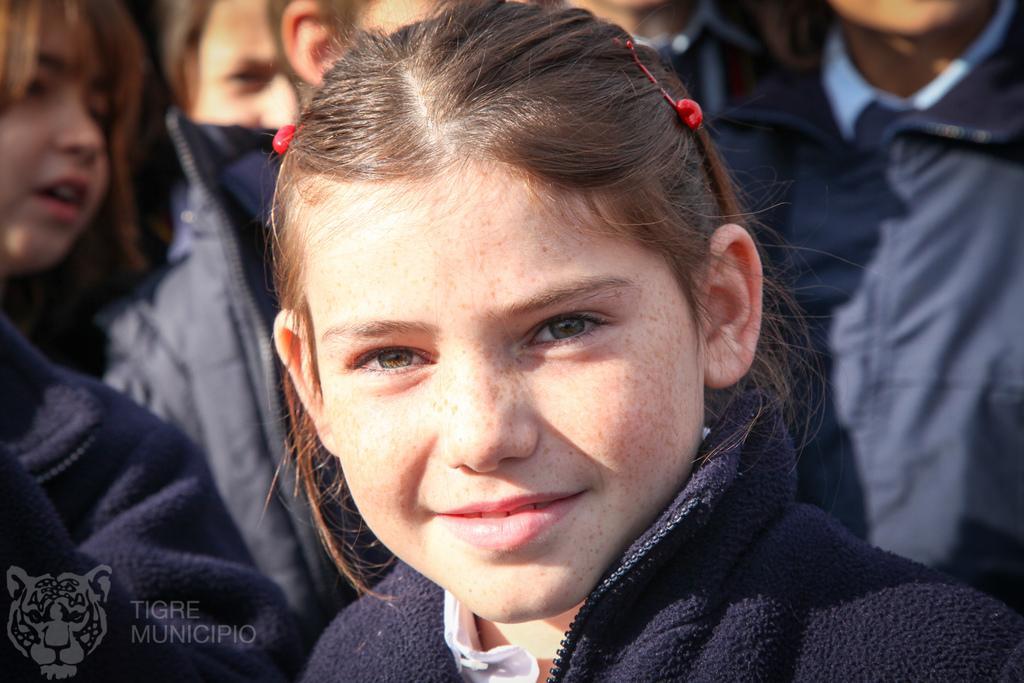Please provide a concise description of this image. In the image there is a girl standing in the front with a black sweatshirt and in the back there are many girls standing. 